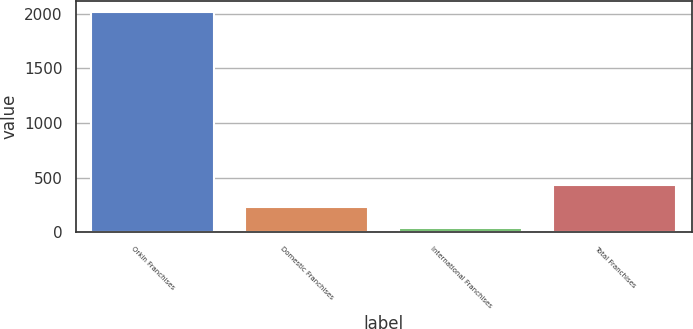<chart> <loc_0><loc_0><loc_500><loc_500><bar_chart><fcel>Orkin Franchises<fcel>Domestic Franchises<fcel>International Franchises<fcel>Total Franchises<nl><fcel>2014<fcel>234.7<fcel>37<fcel>432.4<nl></chart> 